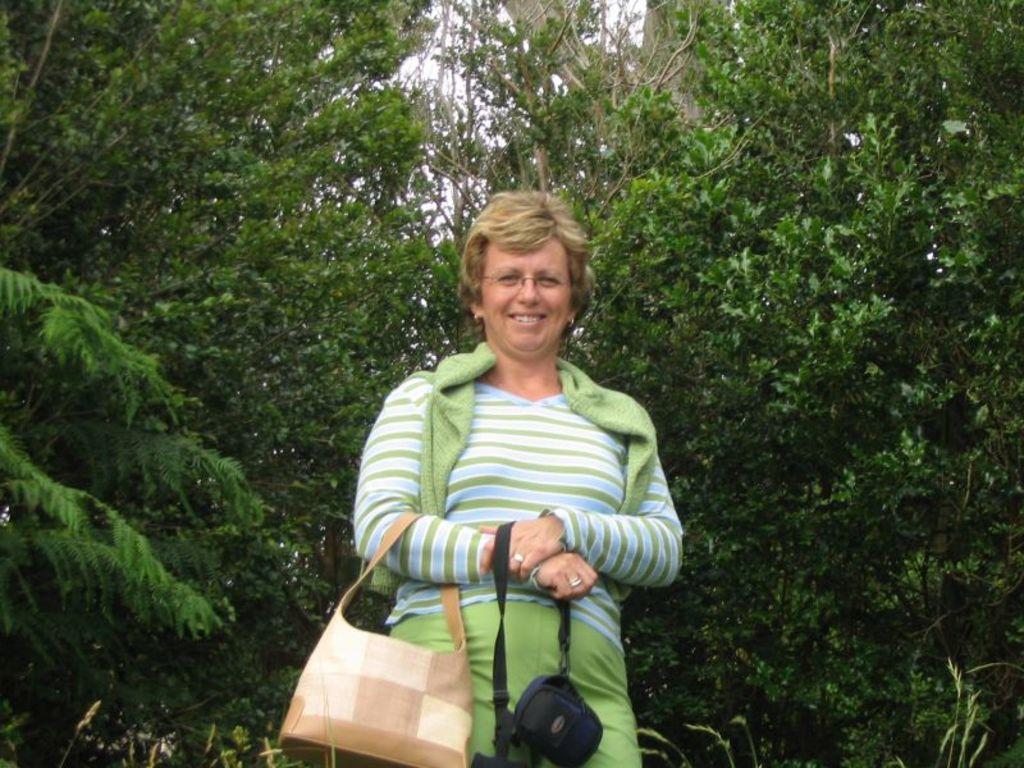How would you summarize this image in a sentence or two? In this image I can see a woman is standing and she is carrying a handbag. In the background I can see number of trees. 